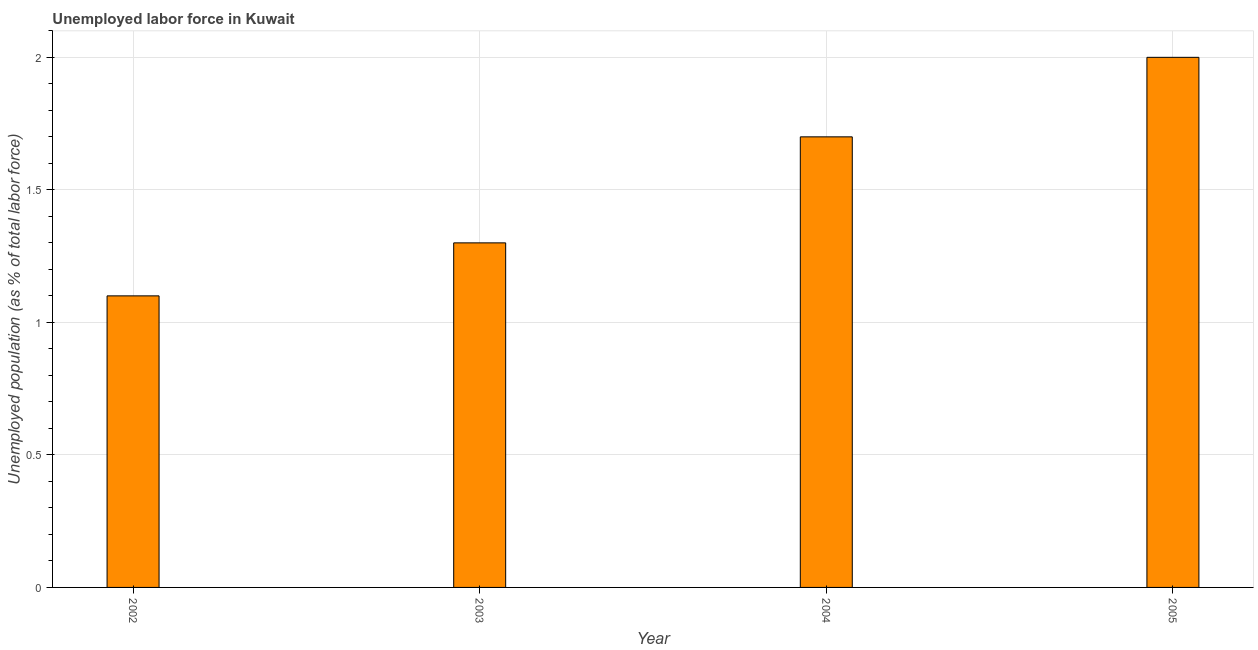What is the title of the graph?
Make the answer very short. Unemployed labor force in Kuwait. What is the label or title of the Y-axis?
Provide a short and direct response. Unemployed population (as % of total labor force). What is the total unemployed population in 2003?
Your response must be concise. 1.3. Across all years, what is the maximum total unemployed population?
Provide a succinct answer. 2. Across all years, what is the minimum total unemployed population?
Offer a very short reply. 1.1. In which year was the total unemployed population minimum?
Ensure brevity in your answer.  2002. What is the sum of the total unemployed population?
Your answer should be compact. 6.1. What is the average total unemployed population per year?
Your response must be concise. 1.52. Do a majority of the years between 2004 and 2005 (inclusive) have total unemployed population greater than 1.9 %?
Your answer should be compact. No. What is the ratio of the total unemployed population in 2002 to that in 2004?
Your answer should be very brief. 0.65. What is the difference between the highest and the lowest total unemployed population?
Your response must be concise. 0.9. In how many years, is the total unemployed population greater than the average total unemployed population taken over all years?
Provide a short and direct response. 2. How many bars are there?
Offer a very short reply. 4. Are the values on the major ticks of Y-axis written in scientific E-notation?
Ensure brevity in your answer.  No. What is the Unemployed population (as % of total labor force) of 2002?
Keep it short and to the point. 1.1. What is the Unemployed population (as % of total labor force) in 2003?
Your response must be concise. 1.3. What is the Unemployed population (as % of total labor force) in 2004?
Provide a succinct answer. 1.7. What is the Unemployed population (as % of total labor force) in 2005?
Keep it short and to the point. 2. What is the difference between the Unemployed population (as % of total labor force) in 2002 and 2003?
Make the answer very short. -0.2. What is the ratio of the Unemployed population (as % of total labor force) in 2002 to that in 2003?
Provide a succinct answer. 0.85. What is the ratio of the Unemployed population (as % of total labor force) in 2002 to that in 2004?
Provide a short and direct response. 0.65. What is the ratio of the Unemployed population (as % of total labor force) in 2002 to that in 2005?
Make the answer very short. 0.55. What is the ratio of the Unemployed population (as % of total labor force) in 2003 to that in 2004?
Provide a succinct answer. 0.77. What is the ratio of the Unemployed population (as % of total labor force) in 2003 to that in 2005?
Offer a very short reply. 0.65. 